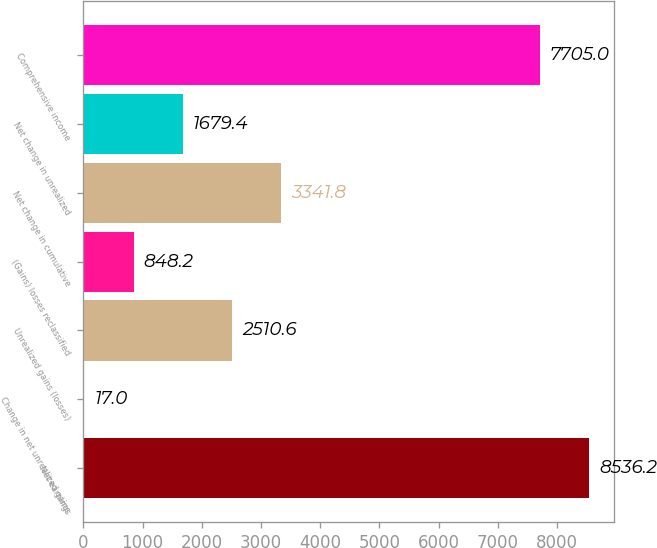<chart> <loc_0><loc_0><loc_500><loc_500><bar_chart><fcel>Net earnings<fcel>Change in net unrealized gains<fcel>Unrealized gains (losses)<fcel>(Gains) losses reclassified<fcel>Net change in cumulative<fcel>Net change in unrealized<fcel>Comprehensive income<nl><fcel>8536.2<fcel>17<fcel>2510.6<fcel>848.2<fcel>3341.8<fcel>1679.4<fcel>7705<nl></chart> 